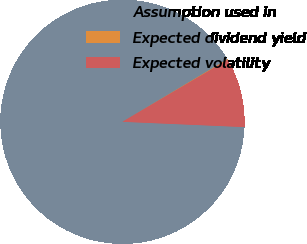<chart> <loc_0><loc_0><loc_500><loc_500><pie_chart><fcel>Assumption used in<fcel>Expected dividend yield<fcel>Expected volatility<nl><fcel>90.77%<fcel>0.08%<fcel>9.15%<nl></chart> 